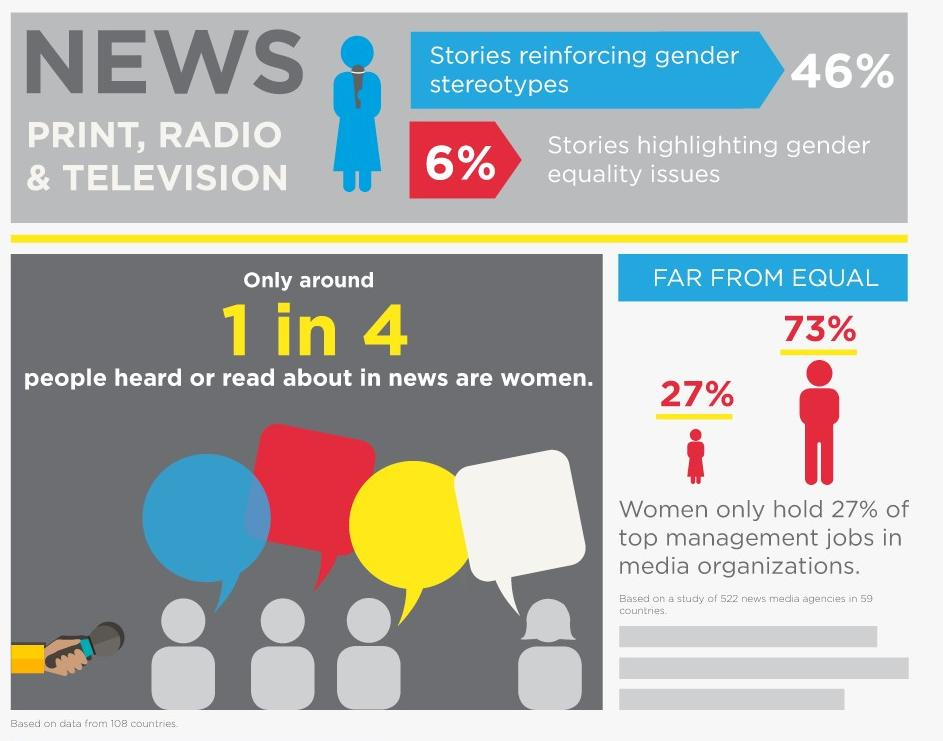List a handful of essential elements in this visual. In a study, it was found that 54% of news stories do not reinforce gender stereotypes. Men hold the majority of top management positions in media organizations. 